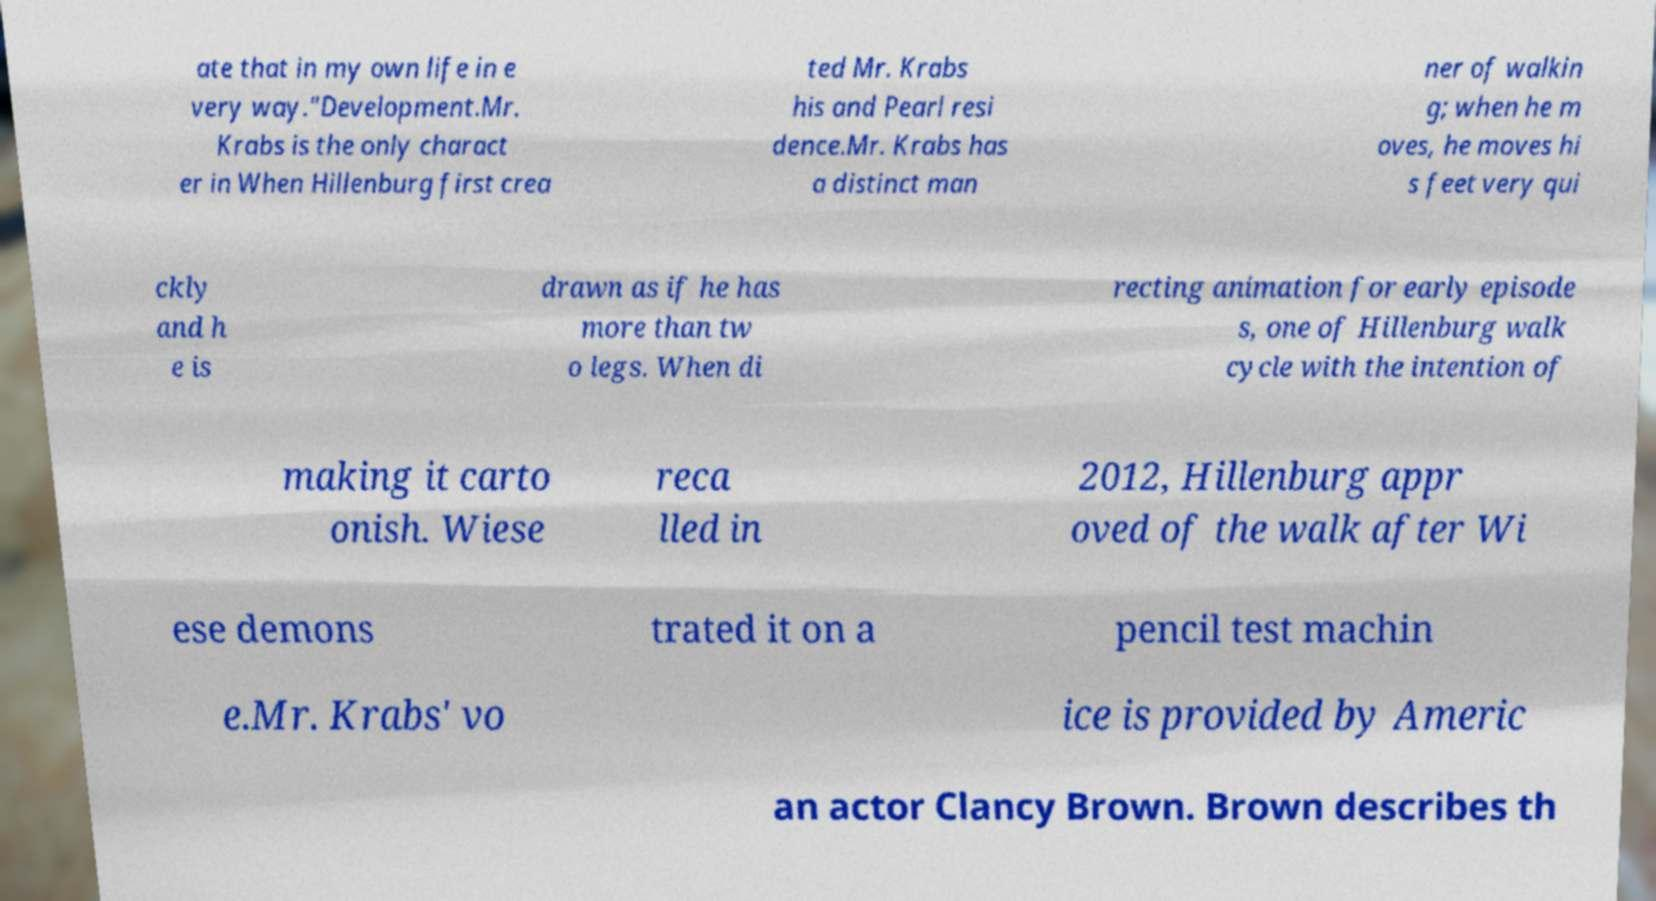For documentation purposes, I need the text within this image transcribed. Could you provide that? ate that in my own life in e very way."Development.Mr. Krabs is the only charact er in When Hillenburg first crea ted Mr. Krabs his and Pearl resi dence.Mr. Krabs has a distinct man ner of walkin g; when he m oves, he moves hi s feet very qui ckly and h e is drawn as if he has more than tw o legs. When di recting animation for early episode s, one of Hillenburg walk cycle with the intention of making it carto onish. Wiese reca lled in 2012, Hillenburg appr oved of the walk after Wi ese demons trated it on a pencil test machin e.Mr. Krabs' vo ice is provided by Americ an actor Clancy Brown. Brown describes th 